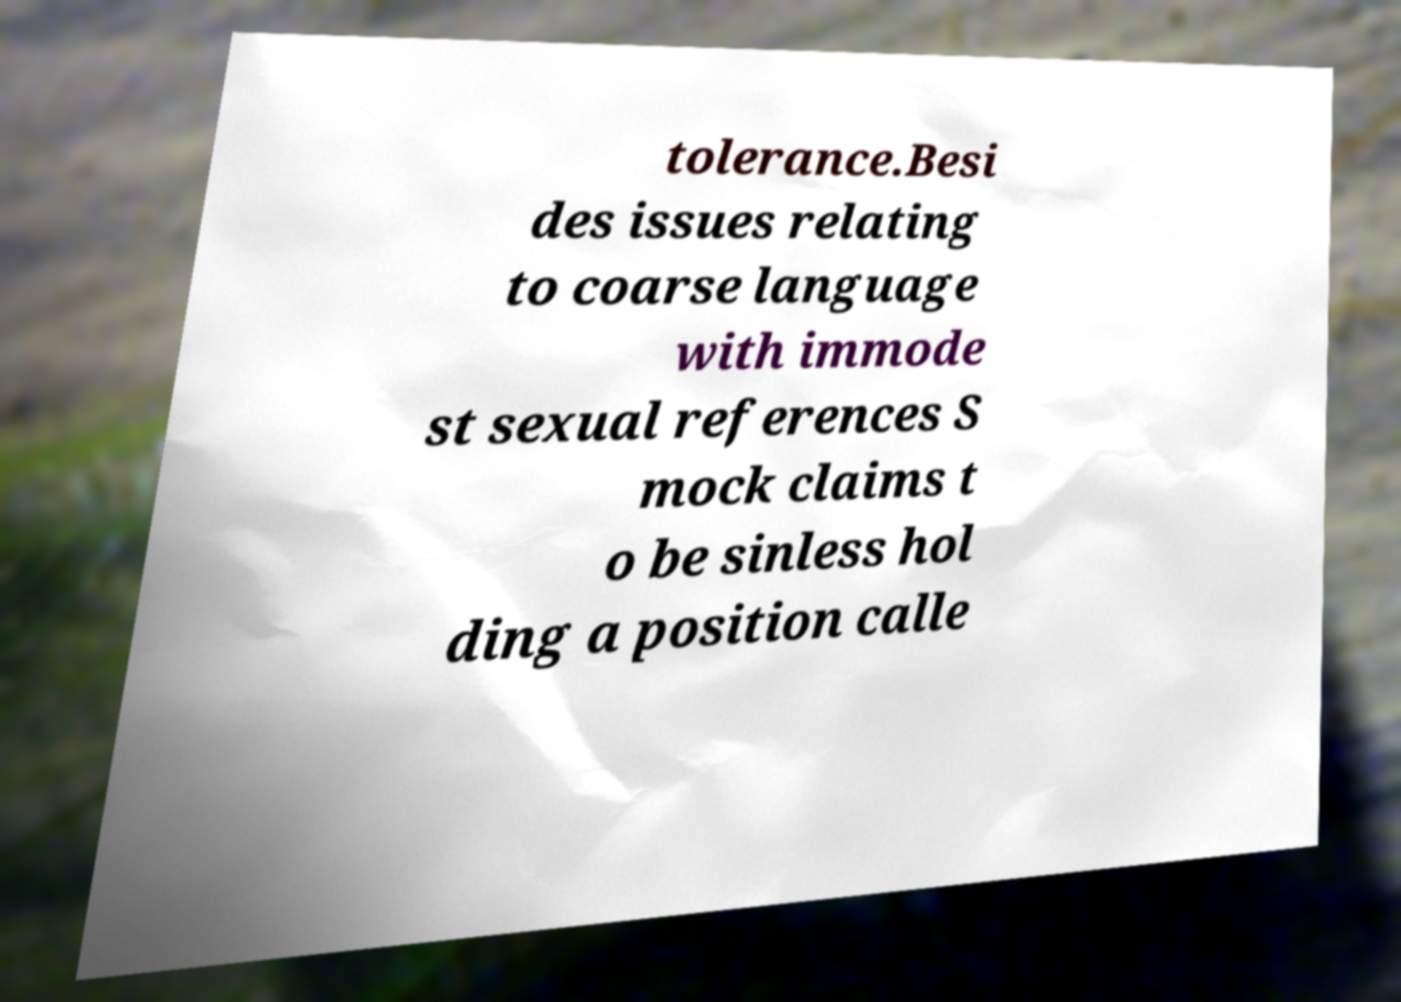Could you assist in decoding the text presented in this image and type it out clearly? tolerance.Besi des issues relating to coarse language with immode st sexual references S mock claims t o be sinless hol ding a position calle 